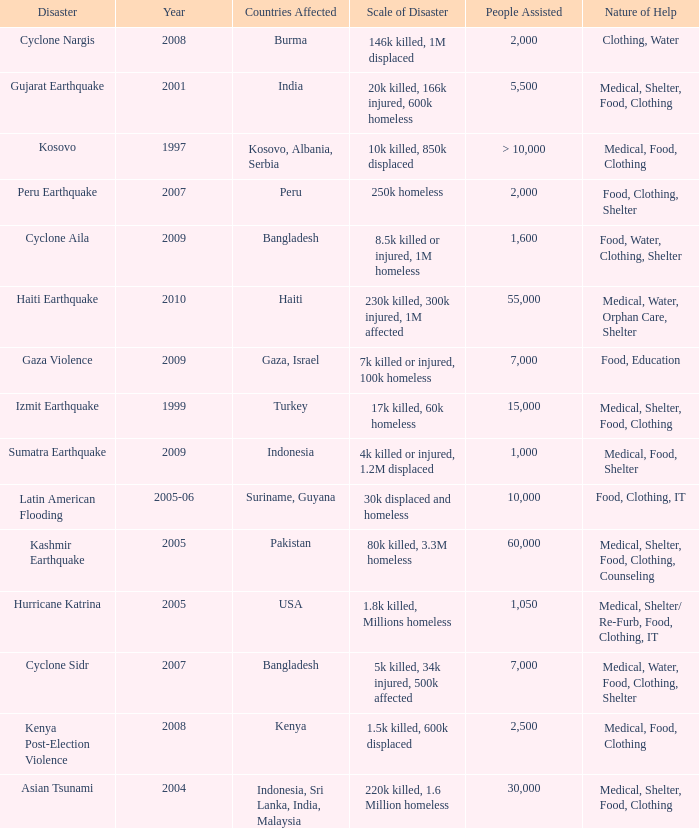What is the scale of disaster for the USA? 1.8k killed, Millions homeless. 